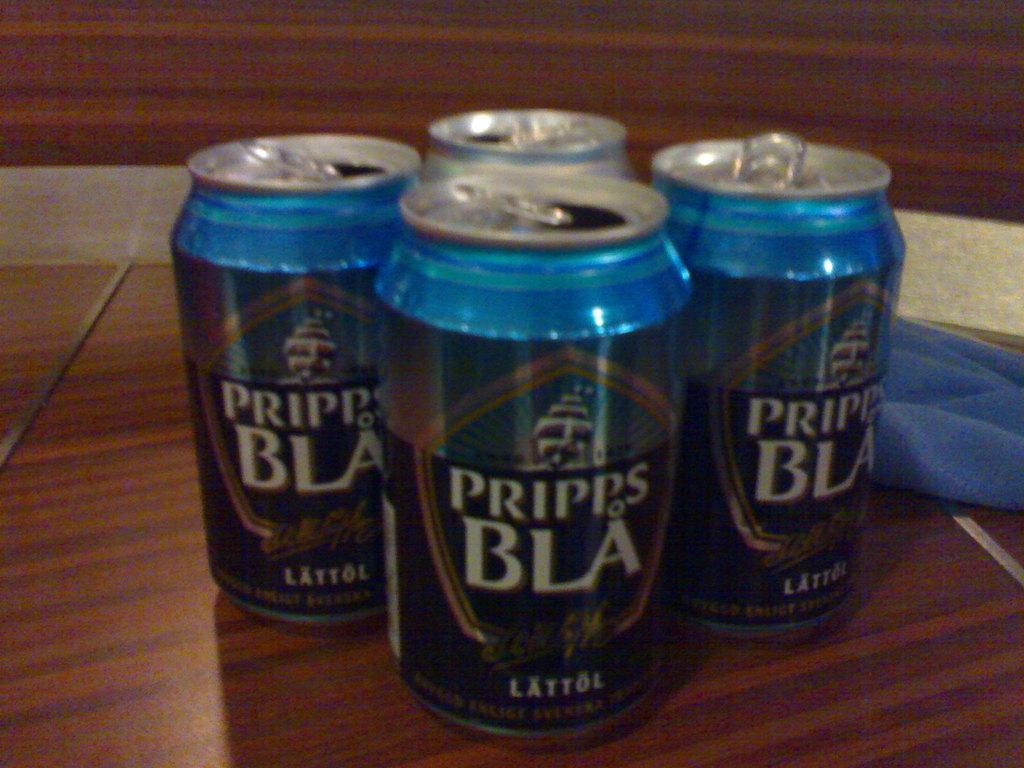What brand is this beverage?
Your answer should be compact. Pripps bla. 